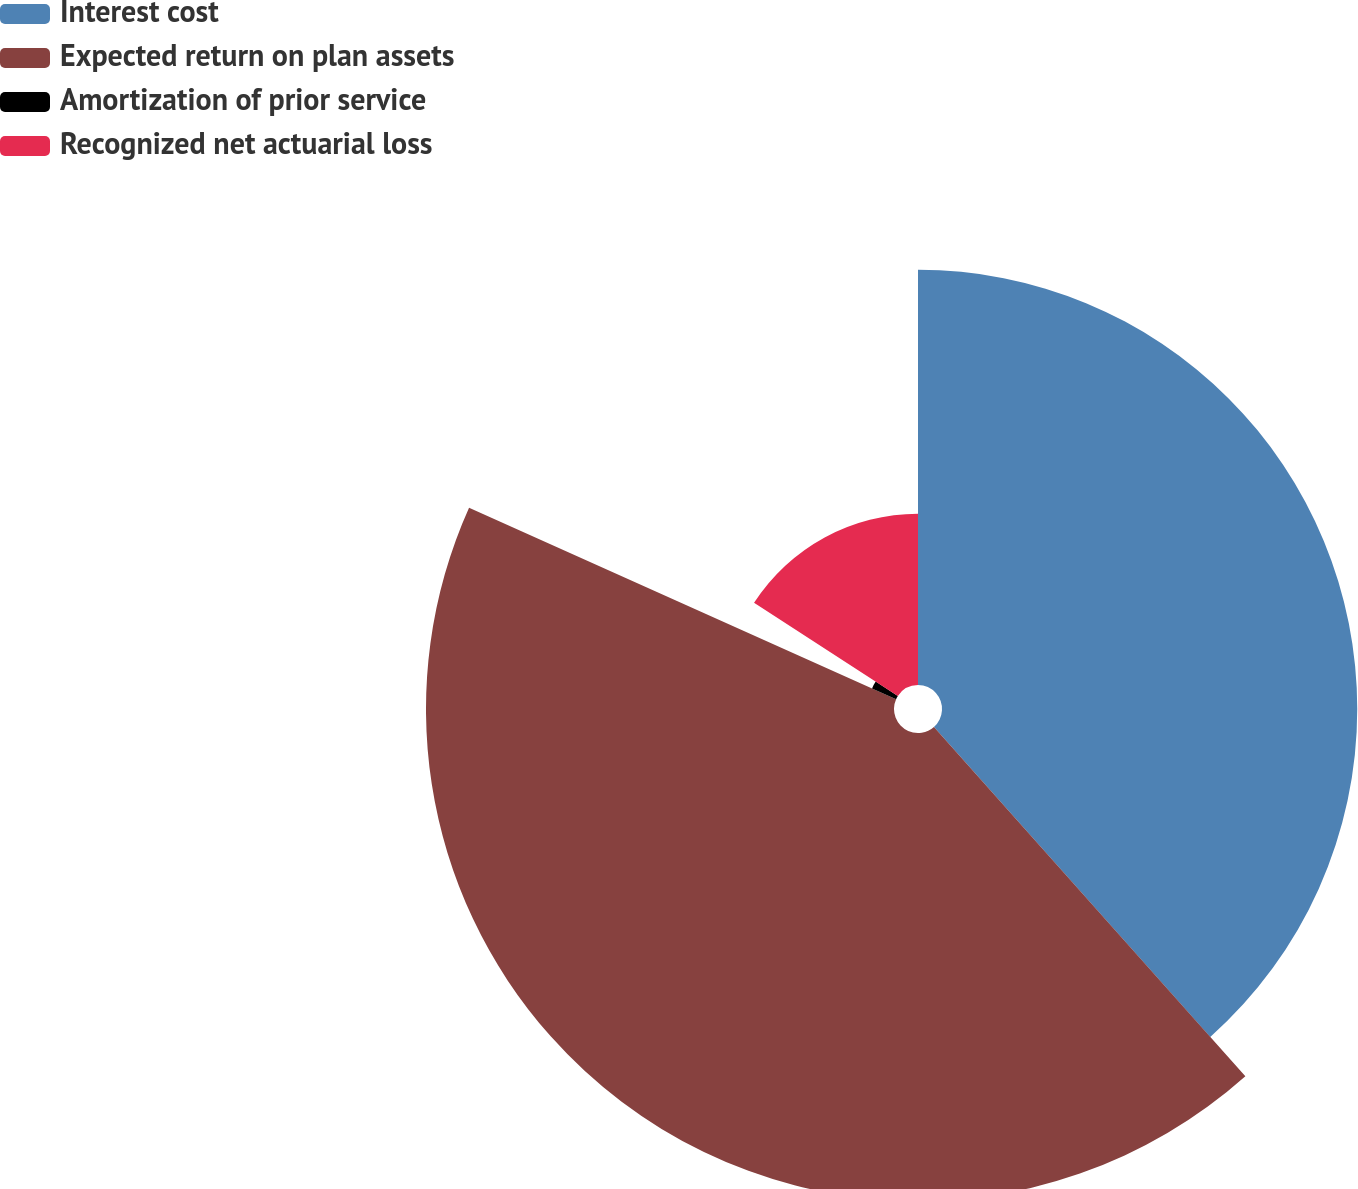<chart> <loc_0><loc_0><loc_500><loc_500><pie_chart><fcel>Interest cost<fcel>Expected return on plan assets<fcel>Amortization of prior service<fcel>Recognized net actuarial loss<nl><fcel>38.41%<fcel>43.29%<fcel>2.44%<fcel>15.85%<nl></chart> 